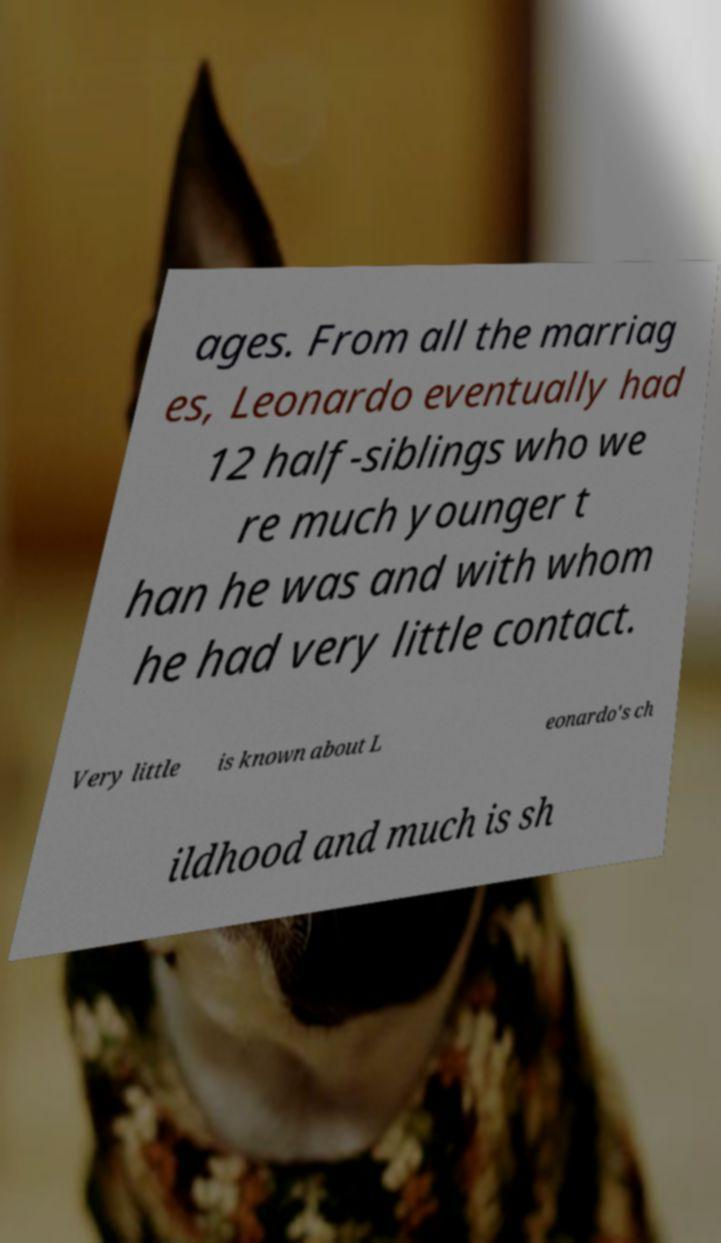What messages or text are displayed in this image? I need them in a readable, typed format. ages. From all the marriag es, Leonardo eventually had 12 half-siblings who we re much younger t han he was and with whom he had very little contact. Very little is known about L eonardo's ch ildhood and much is sh 